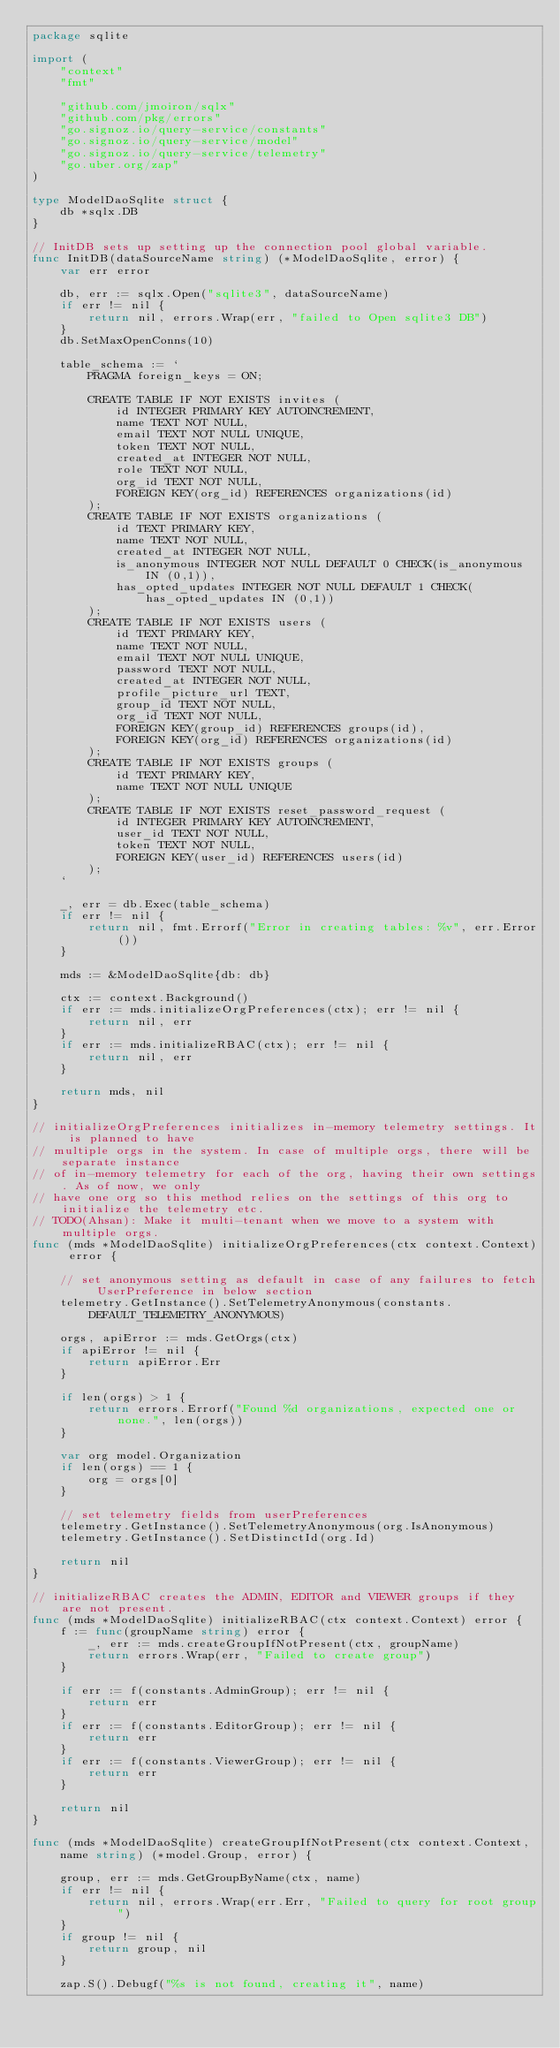<code> <loc_0><loc_0><loc_500><loc_500><_Go_>package sqlite

import (
	"context"
	"fmt"

	"github.com/jmoiron/sqlx"
	"github.com/pkg/errors"
	"go.signoz.io/query-service/constants"
	"go.signoz.io/query-service/model"
	"go.signoz.io/query-service/telemetry"
	"go.uber.org/zap"
)

type ModelDaoSqlite struct {
	db *sqlx.DB
}

// InitDB sets up setting up the connection pool global variable.
func InitDB(dataSourceName string) (*ModelDaoSqlite, error) {
	var err error

	db, err := sqlx.Open("sqlite3", dataSourceName)
	if err != nil {
		return nil, errors.Wrap(err, "failed to Open sqlite3 DB")
	}
	db.SetMaxOpenConns(10)

	table_schema := `
		PRAGMA foreign_keys = ON;

		CREATE TABLE IF NOT EXISTS invites (
			id INTEGER PRIMARY KEY AUTOINCREMENT,
			name TEXT NOT NULL,
			email TEXT NOT NULL UNIQUE,
			token TEXT NOT NULL,
			created_at INTEGER NOT NULL,
			role TEXT NOT NULL,
			org_id TEXT NOT NULL,
			FOREIGN KEY(org_id) REFERENCES organizations(id)
		);
		CREATE TABLE IF NOT EXISTS organizations (
			id TEXT PRIMARY KEY,
			name TEXT NOT NULL,
			created_at INTEGER NOT NULL,
			is_anonymous INTEGER NOT NULL DEFAULT 0 CHECK(is_anonymous IN (0,1)),
			has_opted_updates INTEGER NOT NULL DEFAULT 1 CHECK(has_opted_updates IN (0,1))
		);
		CREATE TABLE IF NOT EXISTS users (
			id TEXT PRIMARY KEY,
			name TEXT NOT NULL,
			email TEXT NOT NULL UNIQUE,
			password TEXT NOT NULL,
			created_at INTEGER NOT NULL,
			profile_picture_url TEXT,
			group_id TEXT NOT NULL,
			org_id TEXT NOT NULL,
			FOREIGN KEY(group_id) REFERENCES groups(id),
			FOREIGN KEY(org_id) REFERENCES organizations(id)
		);
		CREATE TABLE IF NOT EXISTS groups (
			id TEXT PRIMARY KEY,
			name TEXT NOT NULL UNIQUE
		);
		CREATE TABLE IF NOT EXISTS reset_password_request (
			id INTEGER PRIMARY KEY AUTOINCREMENT,
			user_id TEXT NOT NULL,
			token TEXT NOT NULL,
			FOREIGN KEY(user_id) REFERENCES users(id)
		);
	`

	_, err = db.Exec(table_schema)
	if err != nil {
		return nil, fmt.Errorf("Error in creating tables: %v", err.Error())
	}

	mds := &ModelDaoSqlite{db: db}

	ctx := context.Background()
	if err := mds.initializeOrgPreferences(ctx); err != nil {
		return nil, err
	}
	if err := mds.initializeRBAC(ctx); err != nil {
		return nil, err
	}

	return mds, nil
}

// initializeOrgPreferences initializes in-memory telemetry settings. It is planned to have
// multiple orgs in the system. In case of multiple orgs, there will be separate instance
// of in-memory telemetry for each of the org, having their own settings. As of now, we only
// have one org so this method relies on the settings of this org to initialize the telemetry etc.
// TODO(Ahsan): Make it multi-tenant when we move to a system with multiple orgs.
func (mds *ModelDaoSqlite) initializeOrgPreferences(ctx context.Context) error {

	// set anonymous setting as default in case of any failures to fetch UserPreference in below section
	telemetry.GetInstance().SetTelemetryAnonymous(constants.DEFAULT_TELEMETRY_ANONYMOUS)

	orgs, apiError := mds.GetOrgs(ctx)
	if apiError != nil {
		return apiError.Err
	}

	if len(orgs) > 1 {
		return errors.Errorf("Found %d organizations, expected one or none.", len(orgs))
	}

	var org model.Organization
	if len(orgs) == 1 {
		org = orgs[0]
	}

	// set telemetry fields from userPreferences
	telemetry.GetInstance().SetTelemetryAnonymous(org.IsAnonymous)
	telemetry.GetInstance().SetDistinctId(org.Id)

	return nil
}

// initializeRBAC creates the ADMIN, EDITOR and VIEWER groups if they are not present.
func (mds *ModelDaoSqlite) initializeRBAC(ctx context.Context) error {
	f := func(groupName string) error {
		_, err := mds.createGroupIfNotPresent(ctx, groupName)
		return errors.Wrap(err, "Failed to create group")
	}

	if err := f(constants.AdminGroup); err != nil {
		return err
	}
	if err := f(constants.EditorGroup); err != nil {
		return err
	}
	if err := f(constants.ViewerGroup); err != nil {
		return err
	}

	return nil
}

func (mds *ModelDaoSqlite) createGroupIfNotPresent(ctx context.Context,
	name string) (*model.Group, error) {

	group, err := mds.GetGroupByName(ctx, name)
	if err != nil {
		return nil, errors.Wrap(err.Err, "Failed to query for root group")
	}
	if group != nil {
		return group, nil
	}

	zap.S().Debugf("%s is not found, creating it", name)</code> 